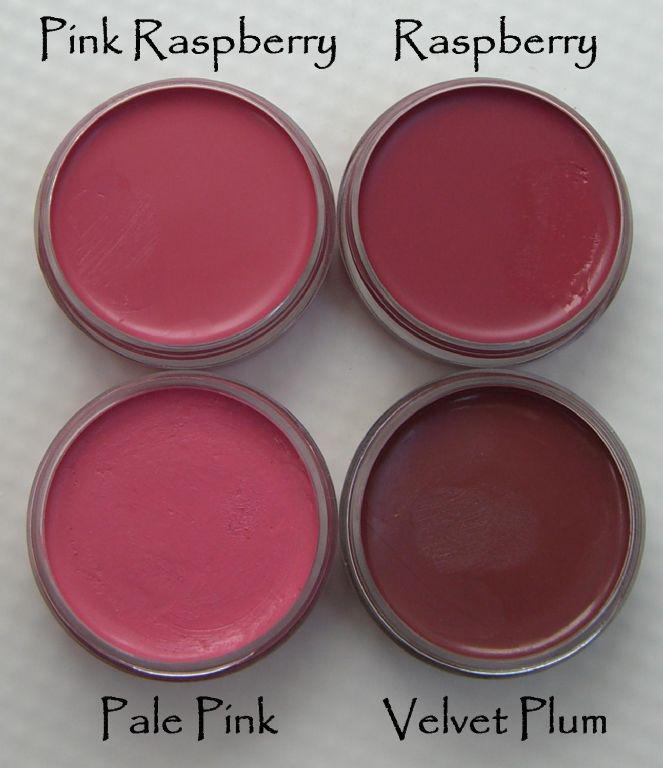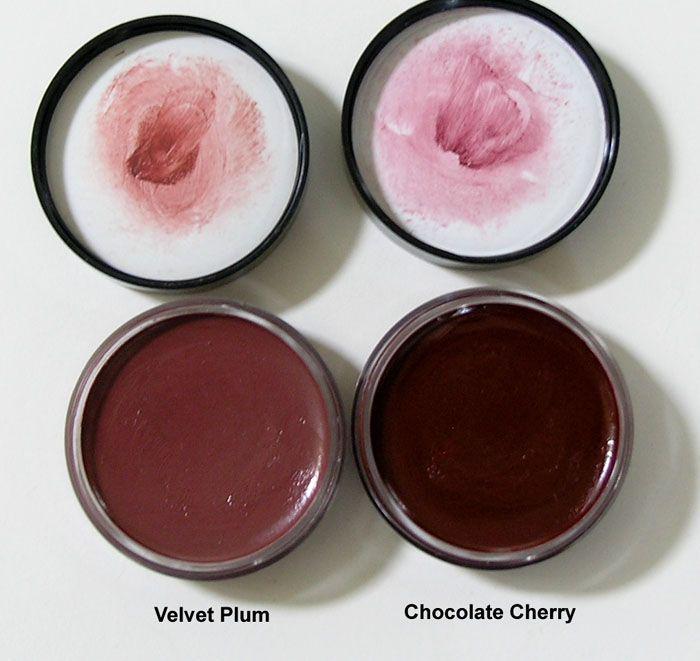The first image is the image on the left, the second image is the image on the right. Assess this claim about the two images: "Each image contains exactly four round disc-shaped items.". Correct or not? Answer yes or no. Yes. 